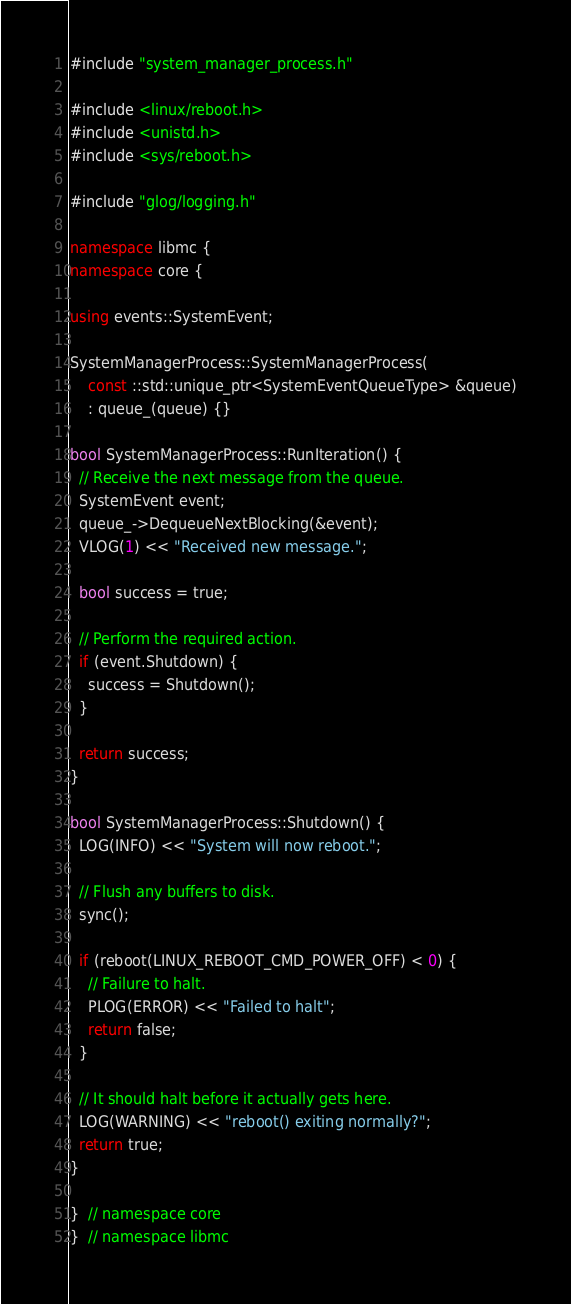<code> <loc_0><loc_0><loc_500><loc_500><_C++_>#include "system_manager_process.h"

#include <linux/reboot.h>
#include <unistd.h>
#include <sys/reboot.h>

#include "glog/logging.h"

namespace libmc {
namespace core {

using events::SystemEvent;

SystemManagerProcess::SystemManagerProcess(
    const ::std::unique_ptr<SystemEventQueueType> &queue)
    : queue_(queue) {}

bool SystemManagerProcess::RunIteration() {
  // Receive the next message from the queue.
  SystemEvent event;
  queue_->DequeueNextBlocking(&event);
  VLOG(1) << "Received new message.";

  bool success = true;

  // Perform the required action.
  if (event.Shutdown) {
    success = Shutdown();
  }

  return success;
}

bool SystemManagerProcess::Shutdown() {
  LOG(INFO) << "System will now reboot.";

  // Flush any buffers to disk.
  sync();

  if (reboot(LINUX_REBOOT_CMD_POWER_OFF) < 0) {
    // Failure to halt.
    PLOG(ERROR) << "Failed to halt";
    return false;
  }

  // It should halt before it actually gets here.
  LOG(WARNING) << "reboot() exiting normally?";
  return true;
}

}  // namespace core
}  // namespace libmc
</code> 